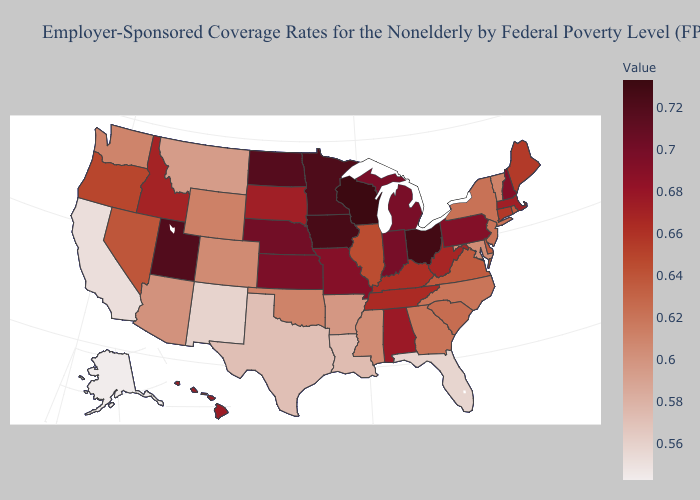Does Vermont have the lowest value in the Northeast?
Short answer required. Yes. Which states have the lowest value in the West?
Be succinct. Alaska. Does Alaska have the lowest value in the West?
Quick response, please. Yes. Which states hav the highest value in the South?
Quick response, please. Alabama. Does Nebraska have the highest value in the USA?
Concise answer only. No. Which states hav the highest value in the South?
Quick response, please. Alabama. Among the states that border Arizona , which have the highest value?
Give a very brief answer. Utah. Does the map have missing data?
Concise answer only. No. Does the map have missing data?
Give a very brief answer. No. Is the legend a continuous bar?
Concise answer only. Yes. 